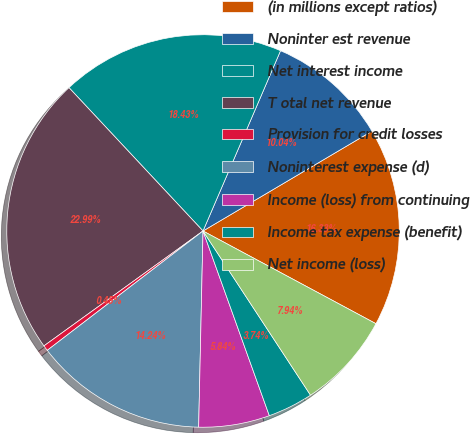Convert chart to OTSL. <chart><loc_0><loc_0><loc_500><loc_500><pie_chart><fcel>(in millions except ratios)<fcel>Noninter est revenue<fcel>Net interest income<fcel>T otal net revenue<fcel>Provision for credit losses<fcel>Noninterest expense (d)<fcel>Income (loss) from continuing<fcel>Income tax expense (benefit)<fcel>Net income (loss)<nl><fcel>16.33%<fcel>10.04%<fcel>18.43%<fcel>22.99%<fcel>0.45%<fcel>14.24%<fcel>5.84%<fcel>3.74%<fcel>7.94%<nl></chart> 